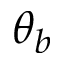<formula> <loc_0><loc_0><loc_500><loc_500>\theta _ { b }</formula> 